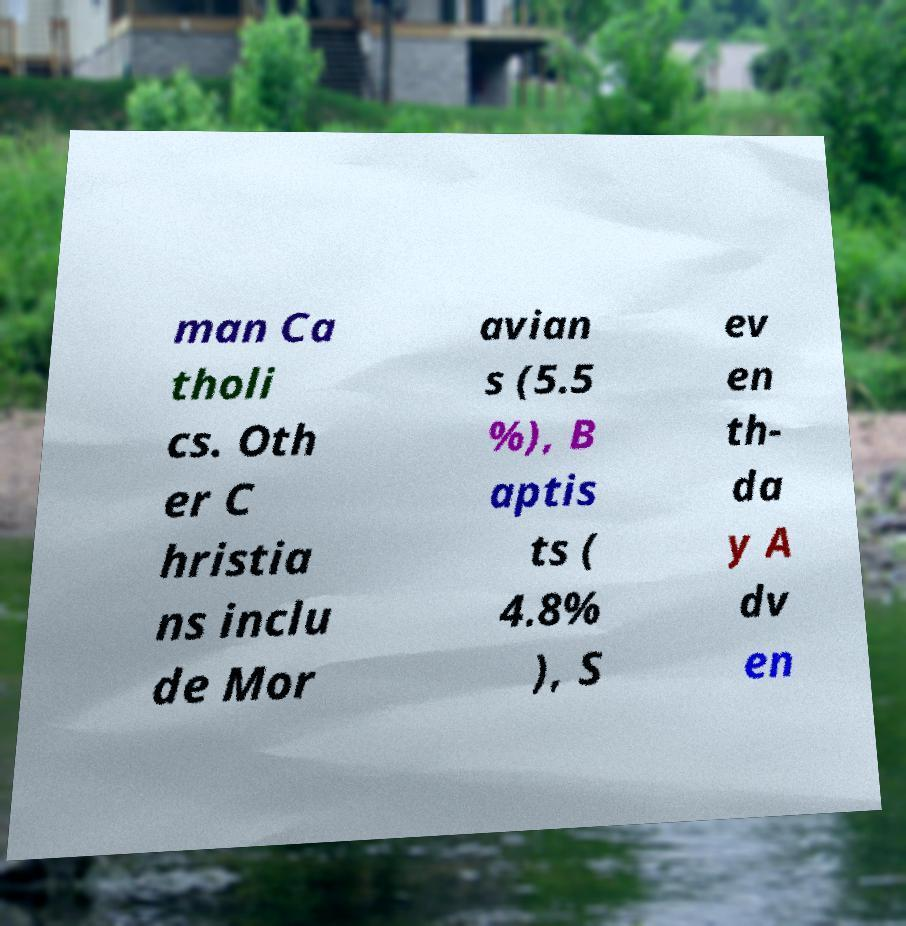Could you assist in decoding the text presented in this image and type it out clearly? man Ca tholi cs. Oth er C hristia ns inclu de Mor avian s (5.5 %), B aptis ts ( 4.8% ), S ev en th- da y A dv en 